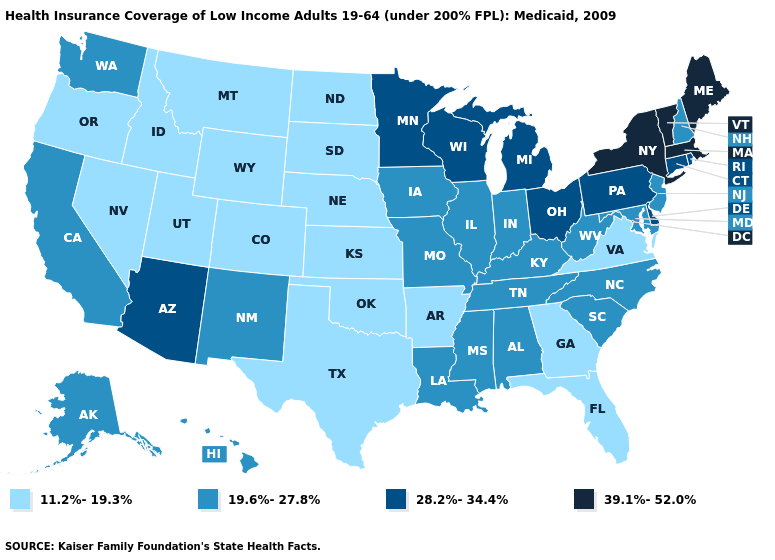What is the value of Colorado?
Write a very short answer. 11.2%-19.3%. Name the states that have a value in the range 39.1%-52.0%?
Short answer required. Maine, Massachusetts, New York, Vermont. What is the highest value in the MidWest ?
Short answer required. 28.2%-34.4%. What is the value of Wyoming?
Quick response, please. 11.2%-19.3%. Does Maryland have the same value as West Virginia?
Write a very short answer. Yes. Which states have the lowest value in the MidWest?
Be succinct. Kansas, Nebraska, North Dakota, South Dakota. Does the map have missing data?
Be succinct. No. What is the lowest value in the USA?
Write a very short answer. 11.2%-19.3%. Name the states that have a value in the range 11.2%-19.3%?
Write a very short answer. Arkansas, Colorado, Florida, Georgia, Idaho, Kansas, Montana, Nebraska, Nevada, North Dakota, Oklahoma, Oregon, South Dakota, Texas, Utah, Virginia, Wyoming. What is the value of Minnesota?
Answer briefly. 28.2%-34.4%. Does the map have missing data?
Give a very brief answer. No. What is the highest value in states that border Maryland?
Be succinct. 28.2%-34.4%. Does North Dakota have a lower value than Colorado?
Write a very short answer. No. What is the value of Alaska?
Answer briefly. 19.6%-27.8%. 